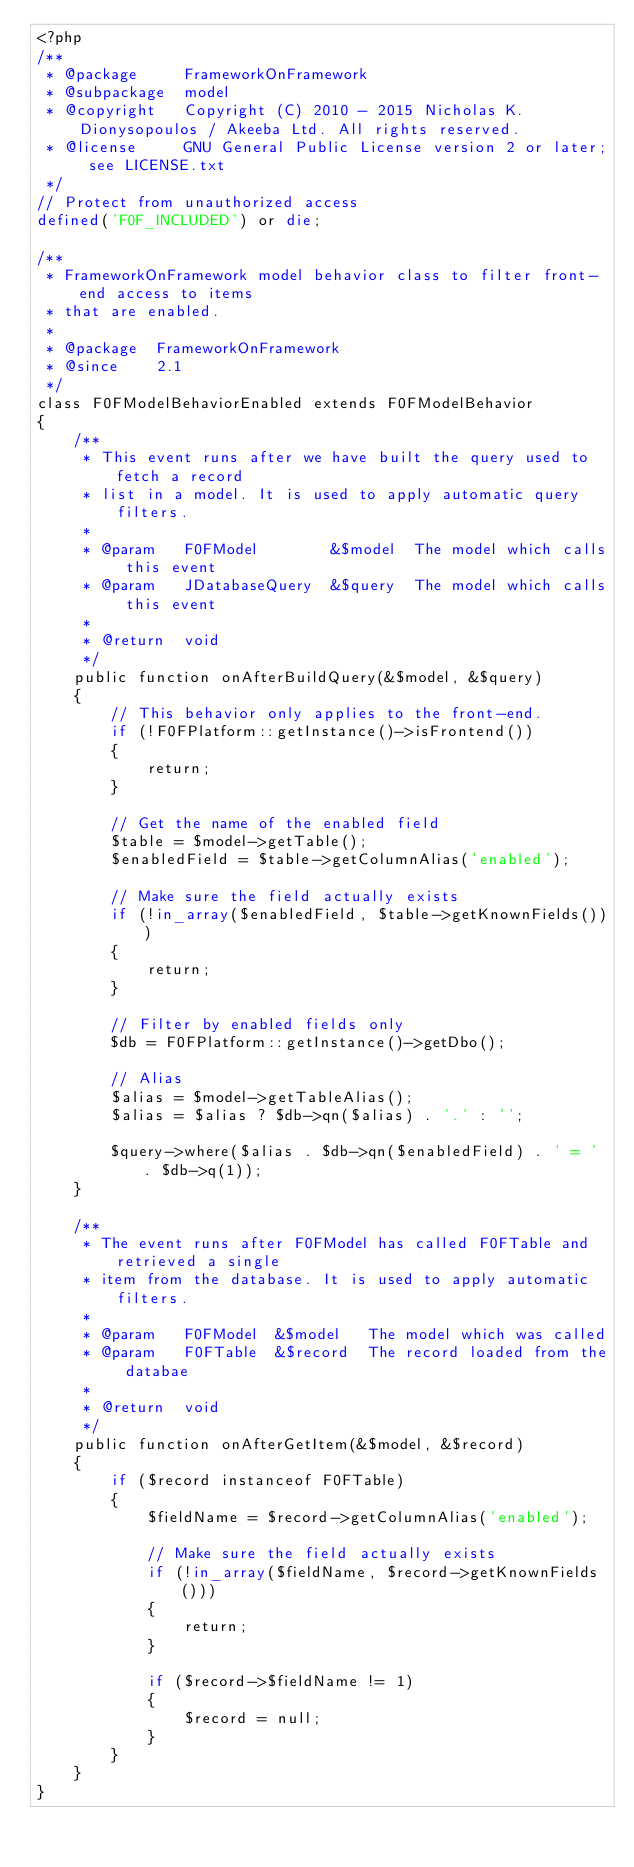Convert code to text. <code><loc_0><loc_0><loc_500><loc_500><_PHP_><?php
/**
 * @package     FrameworkOnFramework
 * @subpackage  model
 * @copyright   Copyright (C) 2010 - 2015 Nicholas K. Dionysopoulos / Akeeba Ltd. All rights reserved.
 * @license     GNU General Public License version 2 or later; see LICENSE.txt
 */
// Protect from unauthorized access
defined('F0F_INCLUDED') or die;

/**
 * FrameworkOnFramework model behavior class to filter front-end access to items
 * that are enabled.
 *
 * @package  FrameworkOnFramework
 * @since    2.1
 */
class F0FModelBehaviorEnabled extends F0FModelBehavior
{
	/**
	 * This event runs after we have built the query used to fetch a record
	 * list in a model. It is used to apply automatic query filters.
	 *
	 * @param   F0FModel        &$model  The model which calls this event
	 * @param   JDatabaseQuery  &$query  The model which calls this event
	 *
	 * @return  void
	 */
	public function onAfterBuildQuery(&$model, &$query)
	{
		// This behavior only applies to the front-end.
		if (!F0FPlatform::getInstance()->isFrontend())
		{
			return;
		}

		// Get the name of the enabled field
		$table = $model->getTable();
		$enabledField = $table->getColumnAlias('enabled');

		// Make sure the field actually exists
		if (!in_array($enabledField, $table->getKnownFields()))
		{
			return;
		}

		// Filter by enabled fields only
		$db = F0FPlatform::getInstance()->getDbo();

		// Alias
		$alias = $model->getTableAlias();
		$alias = $alias ? $db->qn($alias) . '.' : '';

		$query->where($alias . $db->qn($enabledField) . ' = ' . $db->q(1));
	}

	/**
	 * The event runs after F0FModel has called F0FTable and retrieved a single
	 * item from the database. It is used to apply automatic filters.
	 *
	 * @param   F0FModel  &$model   The model which was called
	 * @param   F0FTable  &$record  The record loaded from the databae
	 *
	 * @return  void
	 */
	public function onAfterGetItem(&$model, &$record)
	{
		if ($record instanceof F0FTable)
		{
			$fieldName = $record->getColumnAlias('enabled');

			// Make sure the field actually exists
			if (!in_array($fieldName, $record->getKnownFields()))
			{
				return;
			}

			if ($record->$fieldName != 1)
			{
				$record = null;
			}
		}
	}
}
</code> 